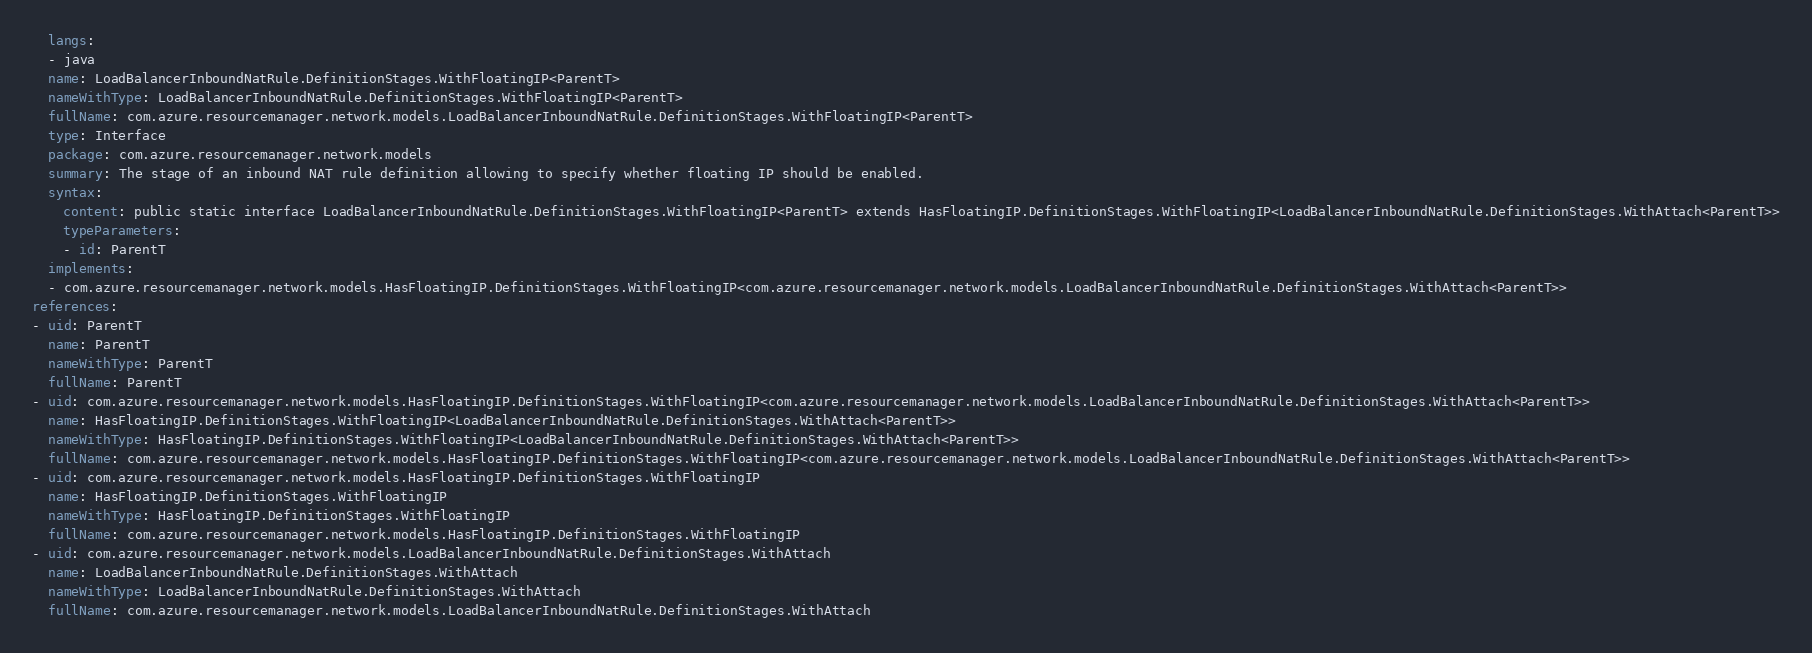Convert code to text. <code><loc_0><loc_0><loc_500><loc_500><_YAML_>  langs:
  - java
  name: LoadBalancerInboundNatRule.DefinitionStages.WithFloatingIP<ParentT>
  nameWithType: LoadBalancerInboundNatRule.DefinitionStages.WithFloatingIP<ParentT>
  fullName: com.azure.resourcemanager.network.models.LoadBalancerInboundNatRule.DefinitionStages.WithFloatingIP<ParentT>
  type: Interface
  package: com.azure.resourcemanager.network.models
  summary: The stage of an inbound NAT rule definition allowing to specify whether floating IP should be enabled.
  syntax:
    content: public static interface LoadBalancerInboundNatRule.DefinitionStages.WithFloatingIP<ParentT> extends HasFloatingIP.DefinitionStages.WithFloatingIP<LoadBalancerInboundNatRule.DefinitionStages.WithAttach<ParentT>>
    typeParameters:
    - id: ParentT
  implements:
  - com.azure.resourcemanager.network.models.HasFloatingIP.DefinitionStages.WithFloatingIP<com.azure.resourcemanager.network.models.LoadBalancerInboundNatRule.DefinitionStages.WithAttach<ParentT>>
references:
- uid: ParentT
  name: ParentT
  nameWithType: ParentT
  fullName: ParentT
- uid: com.azure.resourcemanager.network.models.HasFloatingIP.DefinitionStages.WithFloatingIP<com.azure.resourcemanager.network.models.LoadBalancerInboundNatRule.DefinitionStages.WithAttach<ParentT>>
  name: HasFloatingIP.DefinitionStages.WithFloatingIP<LoadBalancerInboundNatRule.DefinitionStages.WithAttach<ParentT>>
  nameWithType: HasFloatingIP.DefinitionStages.WithFloatingIP<LoadBalancerInboundNatRule.DefinitionStages.WithAttach<ParentT>>
  fullName: com.azure.resourcemanager.network.models.HasFloatingIP.DefinitionStages.WithFloatingIP<com.azure.resourcemanager.network.models.LoadBalancerInboundNatRule.DefinitionStages.WithAttach<ParentT>>
- uid: com.azure.resourcemanager.network.models.HasFloatingIP.DefinitionStages.WithFloatingIP
  name: HasFloatingIP.DefinitionStages.WithFloatingIP
  nameWithType: HasFloatingIP.DefinitionStages.WithFloatingIP
  fullName: com.azure.resourcemanager.network.models.HasFloatingIP.DefinitionStages.WithFloatingIP
- uid: com.azure.resourcemanager.network.models.LoadBalancerInboundNatRule.DefinitionStages.WithAttach
  name: LoadBalancerInboundNatRule.DefinitionStages.WithAttach
  nameWithType: LoadBalancerInboundNatRule.DefinitionStages.WithAttach
  fullName: com.azure.resourcemanager.network.models.LoadBalancerInboundNatRule.DefinitionStages.WithAttach
</code> 